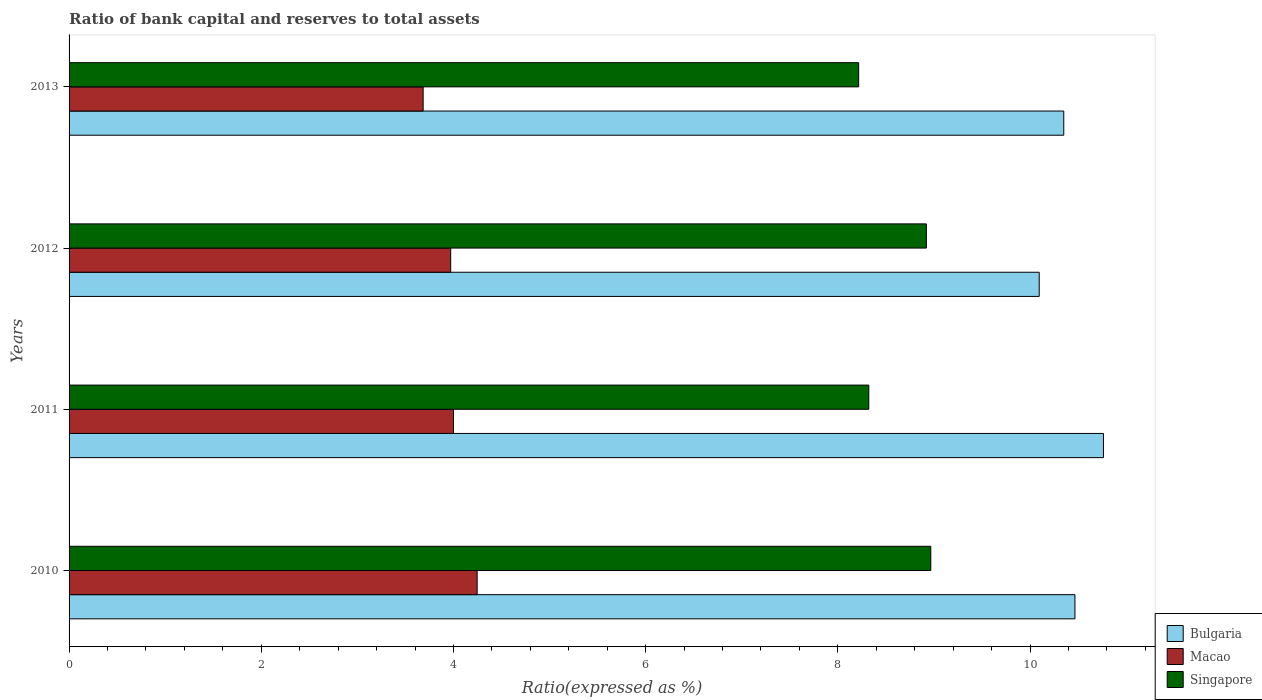How many different coloured bars are there?
Provide a short and direct response. 3. Are the number of bars per tick equal to the number of legend labels?
Give a very brief answer. Yes. How many bars are there on the 3rd tick from the top?
Keep it short and to the point. 3. How many bars are there on the 1st tick from the bottom?
Your answer should be compact. 3. What is the ratio of bank capital and reserves to total assets in Singapore in 2012?
Offer a terse response. 8.92. Across all years, what is the maximum ratio of bank capital and reserves to total assets in Macao?
Offer a terse response. 4.25. Across all years, what is the minimum ratio of bank capital and reserves to total assets in Macao?
Your answer should be very brief. 3.68. In which year was the ratio of bank capital and reserves to total assets in Singapore maximum?
Your answer should be very brief. 2010. What is the total ratio of bank capital and reserves to total assets in Singapore in the graph?
Your response must be concise. 34.43. What is the difference between the ratio of bank capital and reserves to total assets in Singapore in 2010 and that in 2011?
Your answer should be compact. 0.65. What is the difference between the ratio of bank capital and reserves to total assets in Macao in 2011 and the ratio of bank capital and reserves to total assets in Bulgaria in 2013?
Ensure brevity in your answer.  -6.35. What is the average ratio of bank capital and reserves to total assets in Macao per year?
Offer a very short reply. 3.98. In the year 2011, what is the difference between the ratio of bank capital and reserves to total assets in Singapore and ratio of bank capital and reserves to total assets in Macao?
Offer a terse response. 4.32. In how many years, is the ratio of bank capital and reserves to total assets in Macao greater than 5.2 %?
Offer a terse response. 0. What is the ratio of the ratio of bank capital and reserves to total assets in Macao in 2011 to that in 2013?
Provide a succinct answer. 1.09. Is the ratio of bank capital and reserves to total assets in Singapore in 2012 less than that in 2013?
Provide a succinct answer. No. What is the difference between the highest and the second highest ratio of bank capital and reserves to total assets in Macao?
Your answer should be very brief. 0.25. What is the difference between the highest and the lowest ratio of bank capital and reserves to total assets in Macao?
Provide a short and direct response. 0.56. Is the sum of the ratio of bank capital and reserves to total assets in Bulgaria in 2010 and 2013 greater than the maximum ratio of bank capital and reserves to total assets in Singapore across all years?
Your answer should be compact. Yes. What does the 2nd bar from the top in 2010 represents?
Keep it short and to the point. Macao. What does the 3rd bar from the bottom in 2011 represents?
Keep it short and to the point. Singapore. Is it the case that in every year, the sum of the ratio of bank capital and reserves to total assets in Macao and ratio of bank capital and reserves to total assets in Bulgaria is greater than the ratio of bank capital and reserves to total assets in Singapore?
Keep it short and to the point. Yes. How many bars are there?
Your answer should be compact. 12. Are all the bars in the graph horizontal?
Provide a succinct answer. Yes. What is the difference between two consecutive major ticks on the X-axis?
Give a very brief answer. 2. Are the values on the major ticks of X-axis written in scientific E-notation?
Ensure brevity in your answer.  No. Does the graph contain any zero values?
Offer a very short reply. No. Does the graph contain grids?
Your answer should be compact. No. How many legend labels are there?
Give a very brief answer. 3. What is the title of the graph?
Your response must be concise. Ratio of bank capital and reserves to total assets. Does "Philippines" appear as one of the legend labels in the graph?
Make the answer very short. No. What is the label or title of the X-axis?
Your answer should be compact. Ratio(expressed as %). What is the label or title of the Y-axis?
Make the answer very short. Years. What is the Ratio(expressed as %) in Bulgaria in 2010?
Your answer should be very brief. 10.47. What is the Ratio(expressed as %) of Macao in 2010?
Provide a short and direct response. 4.25. What is the Ratio(expressed as %) of Singapore in 2010?
Keep it short and to the point. 8.97. What is the Ratio(expressed as %) in Bulgaria in 2011?
Your response must be concise. 10.76. What is the Ratio(expressed as %) in Macao in 2011?
Provide a succinct answer. 4. What is the Ratio(expressed as %) in Singapore in 2011?
Keep it short and to the point. 8.32. What is the Ratio(expressed as %) of Bulgaria in 2012?
Your answer should be compact. 10.1. What is the Ratio(expressed as %) of Macao in 2012?
Your answer should be very brief. 3.97. What is the Ratio(expressed as %) in Singapore in 2012?
Offer a very short reply. 8.92. What is the Ratio(expressed as %) in Bulgaria in 2013?
Offer a very short reply. 10.35. What is the Ratio(expressed as %) in Macao in 2013?
Your response must be concise. 3.68. What is the Ratio(expressed as %) of Singapore in 2013?
Provide a short and direct response. 8.22. Across all years, what is the maximum Ratio(expressed as %) in Bulgaria?
Your answer should be very brief. 10.76. Across all years, what is the maximum Ratio(expressed as %) in Macao?
Keep it short and to the point. 4.25. Across all years, what is the maximum Ratio(expressed as %) of Singapore?
Provide a short and direct response. 8.97. Across all years, what is the minimum Ratio(expressed as %) in Bulgaria?
Give a very brief answer. 10.1. Across all years, what is the minimum Ratio(expressed as %) of Macao?
Your response must be concise. 3.68. Across all years, what is the minimum Ratio(expressed as %) of Singapore?
Keep it short and to the point. 8.22. What is the total Ratio(expressed as %) of Bulgaria in the graph?
Provide a short and direct response. 41.68. What is the total Ratio(expressed as %) of Macao in the graph?
Ensure brevity in your answer.  15.9. What is the total Ratio(expressed as %) of Singapore in the graph?
Offer a very short reply. 34.43. What is the difference between the Ratio(expressed as %) in Bulgaria in 2010 and that in 2011?
Keep it short and to the point. -0.3. What is the difference between the Ratio(expressed as %) of Macao in 2010 and that in 2011?
Ensure brevity in your answer.  0.25. What is the difference between the Ratio(expressed as %) of Singapore in 2010 and that in 2011?
Offer a terse response. 0.65. What is the difference between the Ratio(expressed as %) of Bulgaria in 2010 and that in 2012?
Make the answer very short. 0.37. What is the difference between the Ratio(expressed as %) of Macao in 2010 and that in 2012?
Your answer should be compact. 0.28. What is the difference between the Ratio(expressed as %) of Singapore in 2010 and that in 2012?
Provide a short and direct response. 0.05. What is the difference between the Ratio(expressed as %) in Bulgaria in 2010 and that in 2013?
Make the answer very short. 0.12. What is the difference between the Ratio(expressed as %) of Macao in 2010 and that in 2013?
Provide a short and direct response. 0.56. What is the difference between the Ratio(expressed as %) of Singapore in 2010 and that in 2013?
Keep it short and to the point. 0.75. What is the difference between the Ratio(expressed as %) of Bulgaria in 2011 and that in 2012?
Provide a succinct answer. 0.67. What is the difference between the Ratio(expressed as %) in Macao in 2011 and that in 2012?
Give a very brief answer. 0.03. What is the difference between the Ratio(expressed as %) of Singapore in 2011 and that in 2012?
Your answer should be compact. -0.6. What is the difference between the Ratio(expressed as %) of Bulgaria in 2011 and that in 2013?
Provide a succinct answer. 0.41. What is the difference between the Ratio(expressed as %) of Macao in 2011 and that in 2013?
Ensure brevity in your answer.  0.32. What is the difference between the Ratio(expressed as %) of Singapore in 2011 and that in 2013?
Your answer should be compact. 0.11. What is the difference between the Ratio(expressed as %) in Bulgaria in 2012 and that in 2013?
Provide a succinct answer. -0.26. What is the difference between the Ratio(expressed as %) in Macao in 2012 and that in 2013?
Make the answer very short. 0.29. What is the difference between the Ratio(expressed as %) in Singapore in 2012 and that in 2013?
Offer a very short reply. 0.7. What is the difference between the Ratio(expressed as %) in Bulgaria in 2010 and the Ratio(expressed as %) in Macao in 2011?
Provide a succinct answer. 6.47. What is the difference between the Ratio(expressed as %) in Bulgaria in 2010 and the Ratio(expressed as %) in Singapore in 2011?
Your answer should be very brief. 2.15. What is the difference between the Ratio(expressed as %) in Macao in 2010 and the Ratio(expressed as %) in Singapore in 2011?
Your answer should be very brief. -4.08. What is the difference between the Ratio(expressed as %) of Bulgaria in 2010 and the Ratio(expressed as %) of Macao in 2012?
Provide a succinct answer. 6.5. What is the difference between the Ratio(expressed as %) in Bulgaria in 2010 and the Ratio(expressed as %) in Singapore in 2012?
Provide a short and direct response. 1.55. What is the difference between the Ratio(expressed as %) in Macao in 2010 and the Ratio(expressed as %) in Singapore in 2012?
Provide a succinct answer. -4.67. What is the difference between the Ratio(expressed as %) in Bulgaria in 2010 and the Ratio(expressed as %) in Macao in 2013?
Your response must be concise. 6.78. What is the difference between the Ratio(expressed as %) of Bulgaria in 2010 and the Ratio(expressed as %) of Singapore in 2013?
Ensure brevity in your answer.  2.25. What is the difference between the Ratio(expressed as %) in Macao in 2010 and the Ratio(expressed as %) in Singapore in 2013?
Your response must be concise. -3.97. What is the difference between the Ratio(expressed as %) in Bulgaria in 2011 and the Ratio(expressed as %) in Macao in 2012?
Ensure brevity in your answer.  6.79. What is the difference between the Ratio(expressed as %) of Bulgaria in 2011 and the Ratio(expressed as %) of Singapore in 2012?
Offer a very short reply. 1.84. What is the difference between the Ratio(expressed as %) in Macao in 2011 and the Ratio(expressed as %) in Singapore in 2012?
Offer a terse response. -4.92. What is the difference between the Ratio(expressed as %) of Bulgaria in 2011 and the Ratio(expressed as %) of Macao in 2013?
Make the answer very short. 7.08. What is the difference between the Ratio(expressed as %) in Bulgaria in 2011 and the Ratio(expressed as %) in Singapore in 2013?
Offer a terse response. 2.55. What is the difference between the Ratio(expressed as %) of Macao in 2011 and the Ratio(expressed as %) of Singapore in 2013?
Provide a short and direct response. -4.22. What is the difference between the Ratio(expressed as %) in Bulgaria in 2012 and the Ratio(expressed as %) in Macao in 2013?
Provide a succinct answer. 6.41. What is the difference between the Ratio(expressed as %) of Bulgaria in 2012 and the Ratio(expressed as %) of Singapore in 2013?
Your answer should be very brief. 1.88. What is the difference between the Ratio(expressed as %) in Macao in 2012 and the Ratio(expressed as %) in Singapore in 2013?
Make the answer very short. -4.25. What is the average Ratio(expressed as %) of Bulgaria per year?
Provide a short and direct response. 10.42. What is the average Ratio(expressed as %) of Macao per year?
Provide a succinct answer. 3.98. What is the average Ratio(expressed as %) in Singapore per year?
Your response must be concise. 8.61. In the year 2010, what is the difference between the Ratio(expressed as %) of Bulgaria and Ratio(expressed as %) of Macao?
Your answer should be very brief. 6.22. In the year 2010, what is the difference between the Ratio(expressed as %) in Macao and Ratio(expressed as %) in Singapore?
Give a very brief answer. -4.72. In the year 2011, what is the difference between the Ratio(expressed as %) of Bulgaria and Ratio(expressed as %) of Macao?
Your answer should be very brief. 6.76. In the year 2011, what is the difference between the Ratio(expressed as %) of Bulgaria and Ratio(expressed as %) of Singapore?
Your answer should be very brief. 2.44. In the year 2011, what is the difference between the Ratio(expressed as %) of Macao and Ratio(expressed as %) of Singapore?
Your answer should be compact. -4.32. In the year 2012, what is the difference between the Ratio(expressed as %) in Bulgaria and Ratio(expressed as %) in Macao?
Ensure brevity in your answer.  6.12. In the year 2012, what is the difference between the Ratio(expressed as %) of Bulgaria and Ratio(expressed as %) of Singapore?
Give a very brief answer. 1.17. In the year 2012, what is the difference between the Ratio(expressed as %) in Macao and Ratio(expressed as %) in Singapore?
Provide a short and direct response. -4.95. In the year 2013, what is the difference between the Ratio(expressed as %) in Bulgaria and Ratio(expressed as %) in Macao?
Provide a short and direct response. 6.67. In the year 2013, what is the difference between the Ratio(expressed as %) in Bulgaria and Ratio(expressed as %) in Singapore?
Give a very brief answer. 2.13. In the year 2013, what is the difference between the Ratio(expressed as %) in Macao and Ratio(expressed as %) in Singapore?
Your answer should be compact. -4.53. What is the ratio of the Ratio(expressed as %) in Bulgaria in 2010 to that in 2011?
Keep it short and to the point. 0.97. What is the ratio of the Ratio(expressed as %) of Macao in 2010 to that in 2011?
Your answer should be compact. 1.06. What is the ratio of the Ratio(expressed as %) of Singapore in 2010 to that in 2011?
Ensure brevity in your answer.  1.08. What is the ratio of the Ratio(expressed as %) of Bulgaria in 2010 to that in 2012?
Make the answer very short. 1.04. What is the ratio of the Ratio(expressed as %) in Macao in 2010 to that in 2012?
Your answer should be compact. 1.07. What is the ratio of the Ratio(expressed as %) of Bulgaria in 2010 to that in 2013?
Your answer should be very brief. 1.01. What is the ratio of the Ratio(expressed as %) of Macao in 2010 to that in 2013?
Provide a short and direct response. 1.15. What is the ratio of the Ratio(expressed as %) of Singapore in 2010 to that in 2013?
Your answer should be very brief. 1.09. What is the ratio of the Ratio(expressed as %) of Bulgaria in 2011 to that in 2012?
Your answer should be compact. 1.07. What is the ratio of the Ratio(expressed as %) in Macao in 2011 to that in 2012?
Your answer should be very brief. 1.01. What is the ratio of the Ratio(expressed as %) of Singapore in 2011 to that in 2012?
Offer a very short reply. 0.93. What is the ratio of the Ratio(expressed as %) of Bulgaria in 2011 to that in 2013?
Offer a terse response. 1.04. What is the ratio of the Ratio(expressed as %) in Macao in 2011 to that in 2013?
Your answer should be very brief. 1.09. What is the ratio of the Ratio(expressed as %) of Singapore in 2011 to that in 2013?
Your response must be concise. 1.01. What is the ratio of the Ratio(expressed as %) in Bulgaria in 2012 to that in 2013?
Keep it short and to the point. 0.98. What is the ratio of the Ratio(expressed as %) of Macao in 2012 to that in 2013?
Your answer should be compact. 1.08. What is the ratio of the Ratio(expressed as %) in Singapore in 2012 to that in 2013?
Give a very brief answer. 1.09. What is the difference between the highest and the second highest Ratio(expressed as %) of Bulgaria?
Provide a succinct answer. 0.3. What is the difference between the highest and the second highest Ratio(expressed as %) in Macao?
Offer a terse response. 0.25. What is the difference between the highest and the second highest Ratio(expressed as %) in Singapore?
Make the answer very short. 0.05. What is the difference between the highest and the lowest Ratio(expressed as %) in Bulgaria?
Offer a terse response. 0.67. What is the difference between the highest and the lowest Ratio(expressed as %) in Macao?
Ensure brevity in your answer.  0.56. What is the difference between the highest and the lowest Ratio(expressed as %) of Singapore?
Your response must be concise. 0.75. 